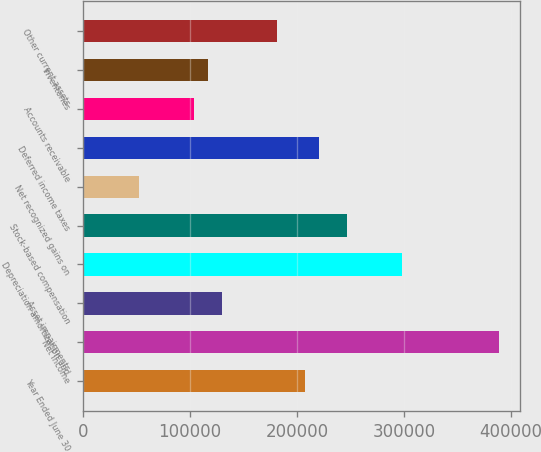Convert chart. <chart><loc_0><loc_0><loc_500><loc_500><bar_chart><fcel>Year Ended June 30<fcel>Net income<fcel>Asset impairments<fcel>Depreciation amortization and<fcel>Stock-based compensation<fcel>Net recognized gains on<fcel>Deferred income taxes<fcel>Accounts receivable<fcel>Inventories<fcel>Other current assets<nl><fcel>207573<fcel>389140<fcel>129758<fcel>298356<fcel>246480<fcel>51943.4<fcel>220542<fcel>103820<fcel>116789<fcel>181634<nl></chart> 